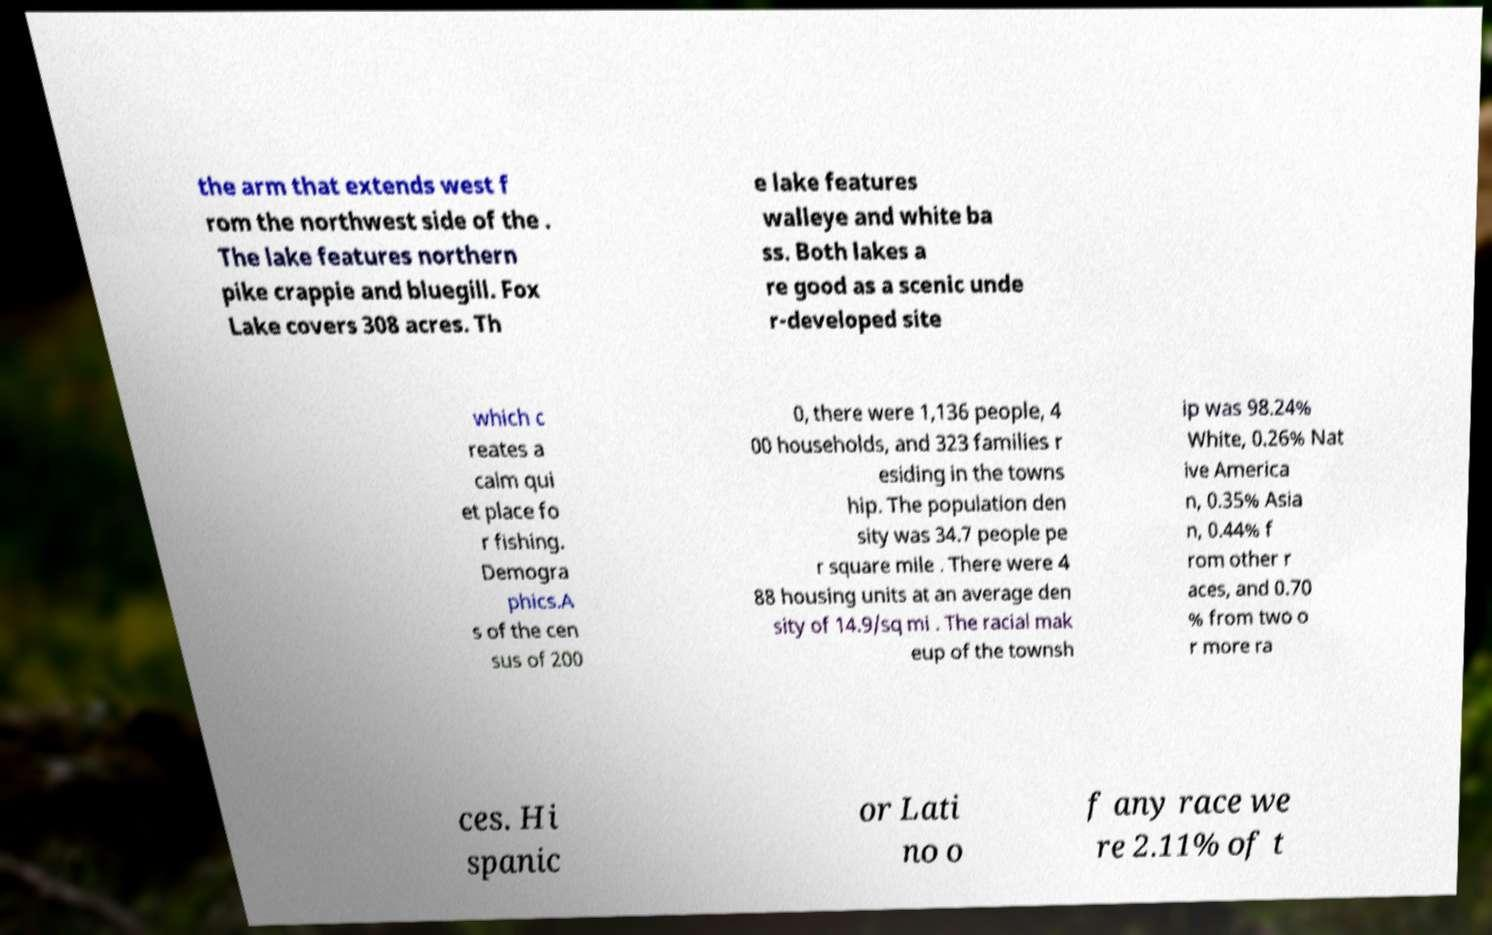Can you read and provide the text displayed in the image?This photo seems to have some interesting text. Can you extract and type it out for me? the arm that extends west f rom the northwest side of the . The lake features northern pike crappie and bluegill. Fox Lake covers 308 acres. Th e lake features walleye and white ba ss. Both lakes a re good as a scenic unde r-developed site which c reates a calm qui et place fo r fishing. Demogra phics.A s of the cen sus of 200 0, there were 1,136 people, 4 00 households, and 323 families r esiding in the towns hip. The population den sity was 34.7 people pe r square mile . There were 4 88 housing units at an average den sity of 14.9/sq mi . The racial mak eup of the townsh ip was 98.24% White, 0.26% Nat ive America n, 0.35% Asia n, 0.44% f rom other r aces, and 0.70 % from two o r more ra ces. Hi spanic or Lati no o f any race we re 2.11% of t 